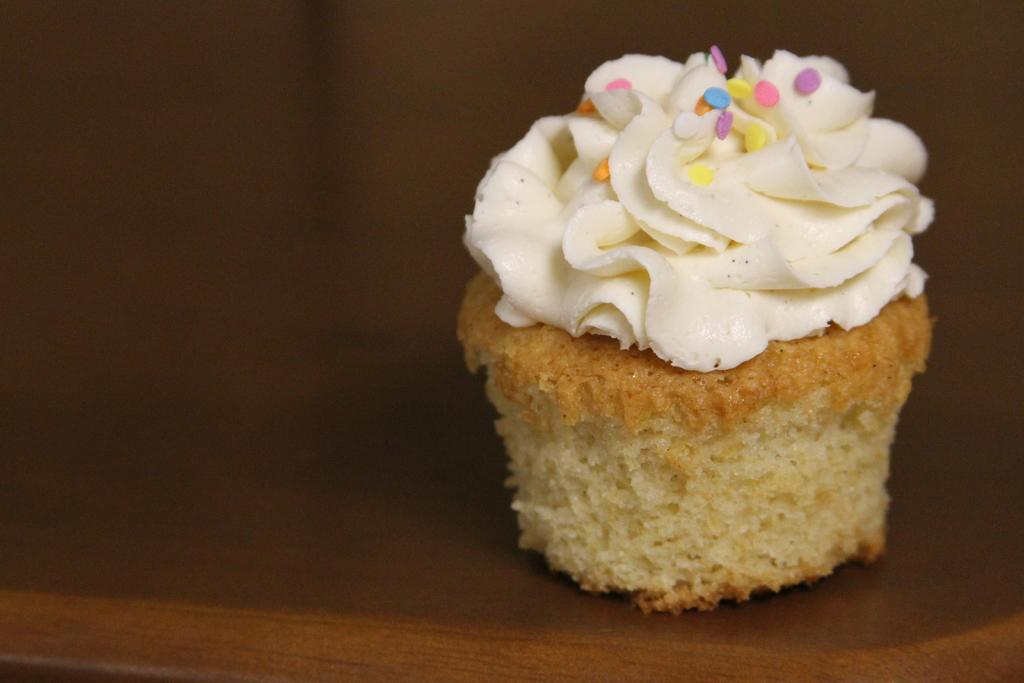What type of dessert is in the image? There is a cupcake in the image. What is on top of the cupcake? The cupcake has cream on it, and there are candies on it. Where is the cupcake located? The cupcake is on a table. What type of society is depicted in the image? There is no society depicted in the image; it features a cupcake with cream and candies on a table. What subject is being taught in the image? There is no teaching or subject being taught in the image; it is a close-up of a cupcake. 